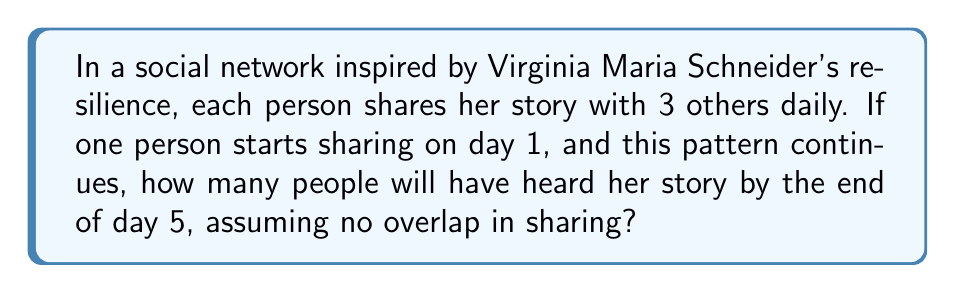Provide a solution to this math problem. Let's approach this step-by-step:

1) On day 1, 1 person knows the story and shares it with 3 others.
   Total at end of day 1: $1 + 3 = 4$

2) On day 2, these 3 new people each share with 3 others.
   New people reached: $3 \times 3 = 9$
   Total at end of day 2: $4 + 9 = 13$

3) On day 3, the 9 people from day 2 each share with 3 others.
   New people reached: $9 \times 3 = 27$
   Total at end of day 3: $13 + 27 = 40$

4) On day 4, the 27 people from day 3 each share with 3 others.
   New people reached: $27 \times 3 = 81$
   Total at end of day 4: $40 + 81 = 121$

5) On day 5, the 81 people from day 4 each share with 3 others.
   New people reached: $81 \times 3 = 243$
   Total at end of day 5: $121 + 243 = 364$

We can observe that this follows the pattern of a geometric series with first term $a = 1$ and common ratio $r = 3$. The sum of this geometric series after 5 terms is given by:

$$S_5 = \frac{a(1-r^5)}{1-r} = \frac{1(1-3^5)}{1-3} = \frac{1-243}{-2} = 364$$

This confirms our step-by-step calculation.
Answer: 364 people 